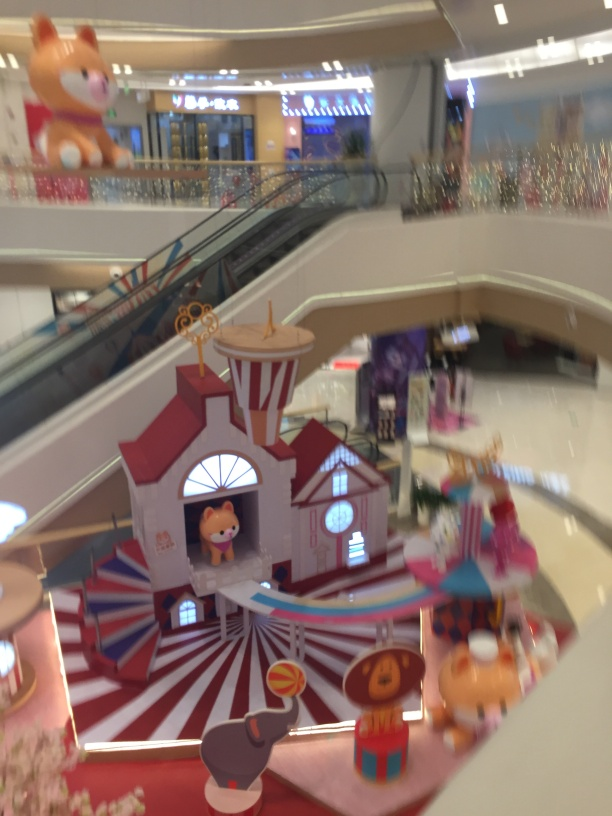How would you interpret the image's composition and what it conveys? The composition of the image, with the focus on the central whimsical structure and blur around the edges, conveys movement and energy, suggesting activity and excitement. This could be interpreted as a snapshot of a lively, dynamic space designed to attract and hold the attention of visitors, especially children, with its fantasy-like elements. 